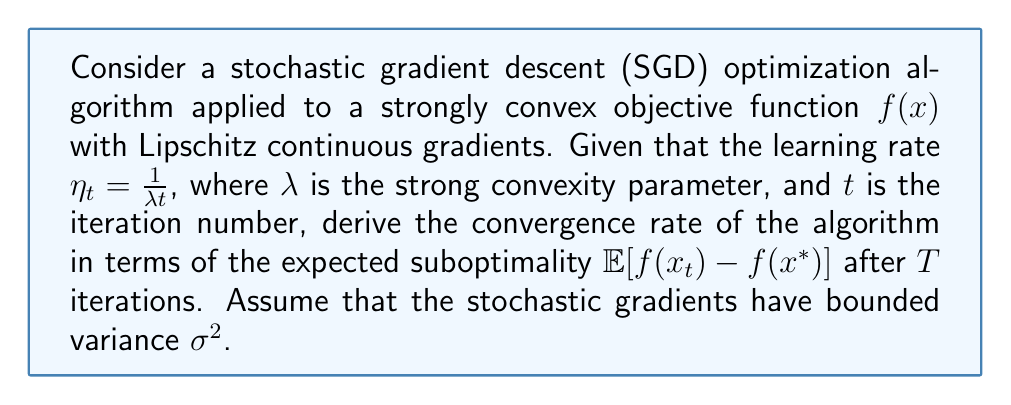Provide a solution to this math problem. To analyze the convergence rate of the SGD algorithm for this problem, we'll follow these steps:

1) For strongly convex functions with Lipschitz continuous gradients, the general convergence rate of SGD is given by:

   $$\mathbb{E}[f(x_t) - f(x^*)] \leq \frac{C_1}{t} + \frac{C_2}{T}$$

   where $C_1$ and $C_2$ are constants that depend on the problem parameters.

2) In our case, with $\eta_t = \frac{1}{\lambda t}$, we need to determine $C_1$ and $C_2$.

3) For strongly convex functions with parameter $\lambda$, and Lipschitz continuous gradients with parameter $L$, it can be shown that:

   $$C_1 = \frac{2L}{\lambda^2}$$

4) The constant $C_2$ is related to the variance of the stochastic gradients:

   $$C_2 = \frac{\sigma^2}{2\lambda}$$

5) Substituting these into our convergence rate equation:

   $$\mathbb{E}[f(x_t) - f(x^*)] \leq \frac{2L}{\lambda^2 t} + \frac{\sigma^2}{2\lambda T}$$

6) This gives us the convergence rate after $T$ iterations:

   $$\mathbb{E}[f(x_T) - f(x^*)] \leq \frac{2L}{\lambda^2 T} + \frac{\sigma^2}{2\lambda T} = \frac{1}{T}\left(\frac{2L}{\lambda^2} + \frac{\sigma^2}{2\lambda}\right)$$

7) Therefore, the convergence rate is $O(\frac{1}{T})$, which is typical for SGD on strongly convex functions.
Answer: The convergence rate of the SGD algorithm after $T$ iterations is $O(\frac{1}{T})$, specifically:

$$\mathbb{E}[f(x_T) - f(x^*)] \leq \frac{1}{T}\left(\frac{2L}{\lambda^2} + \frac{\sigma^2}{2\lambda}\right)$$

where $L$ is the Lipschitz constant of the gradient, $\lambda$ is the strong convexity parameter, and $\sigma^2$ is the variance bound of the stochastic gradients. 